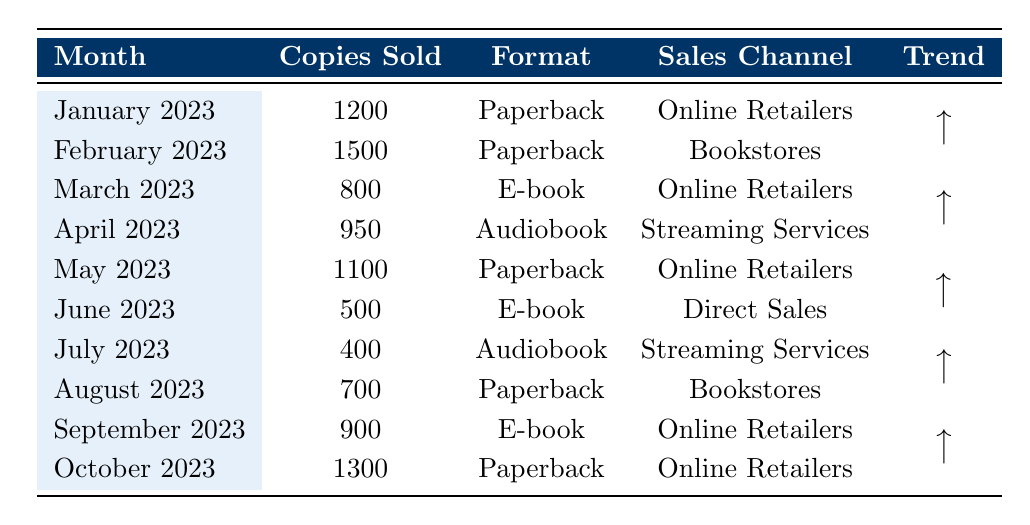What was the highest number of copies sold in a single month? The highest number of copies sold occurred in February 2023, with 1500 copies sold.
Answer: 1500 In which month did the author sell the least number of copies? The month with the least number of copies sold was July 2023, with 400 copies sold.
Answer: July 2023 How many copies were sold in total from January to October 2023? The total copies sold are calculated by adding the monthly sales: 1200 + 1500 + 800 + 950 + 1100 + 500 + 400 + 700 + 900 + 1300 = 6550.
Answer: 6550 What is the average number of copies sold per month from January to October 2023? To find the average, sum the total sales (6550) and divide by the number of months (10): 6550 / 10 = 655.
Answer: 655 Did the sales trend upwards or downwards from June to July 2023? The sales decreased from June (500 copies) to July (400 copies), indicating a downward trend.
Answer: Downward Which sales channel had the highest sales for the book in the given months? The Online Retailers channel had the highest sales, selling 1200 copies in January, 800 in March, 900 in September, and 1300 in October. The total from this channel is 1200 + 800 + 900 + 1300 = 3200 copies.
Answer: Online Retailers Was there any month where the audiobook format had higher sales than the e-book format? Yes, in April 2023, the audiobook sales were 950, which were higher than the e-book sales in March (800) and July (400).
Answer: Yes What is the difference in copies sold between the best and worst-selling months? The difference is between February (1500 copies) and July (400 copies). Subtracting gives 1500 - 400 = 1100 copies.
Answer: 1100 In which format did Lena Morgan see the highest sales in a single month? The highest sales in a single month were for the Paperback format in February 2023 with 1500 copies sold.
Answer: Paperback What was the total number of audiobook sales across all months? Audiobook sales were 950 in April and 400 in July. Summing them gives 950 + 400 = 1350.
Answer: 1350 